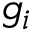Convert formula to latex. <formula><loc_0><loc_0><loc_500><loc_500>g _ { i }</formula> 